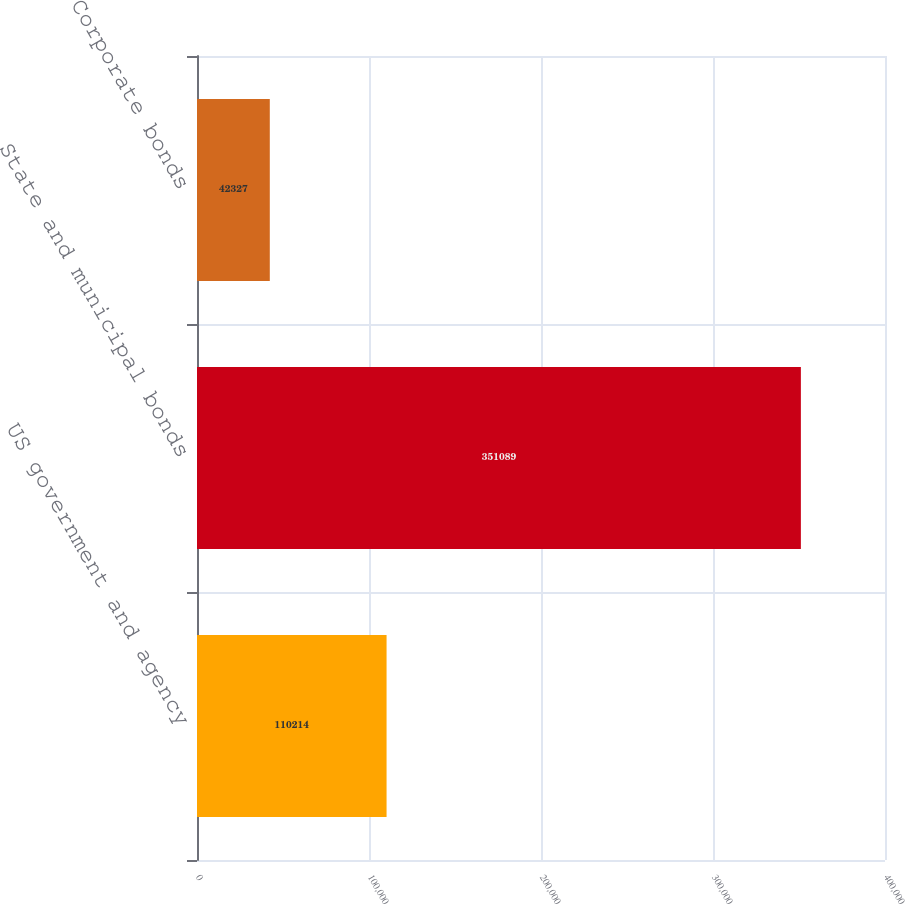Convert chart. <chart><loc_0><loc_0><loc_500><loc_500><bar_chart><fcel>US government and agency<fcel>State and municipal bonds<fcel>Corporate bonds<nl><fcel>110214<fcel>351089<fcel>42327<nl></chart> 